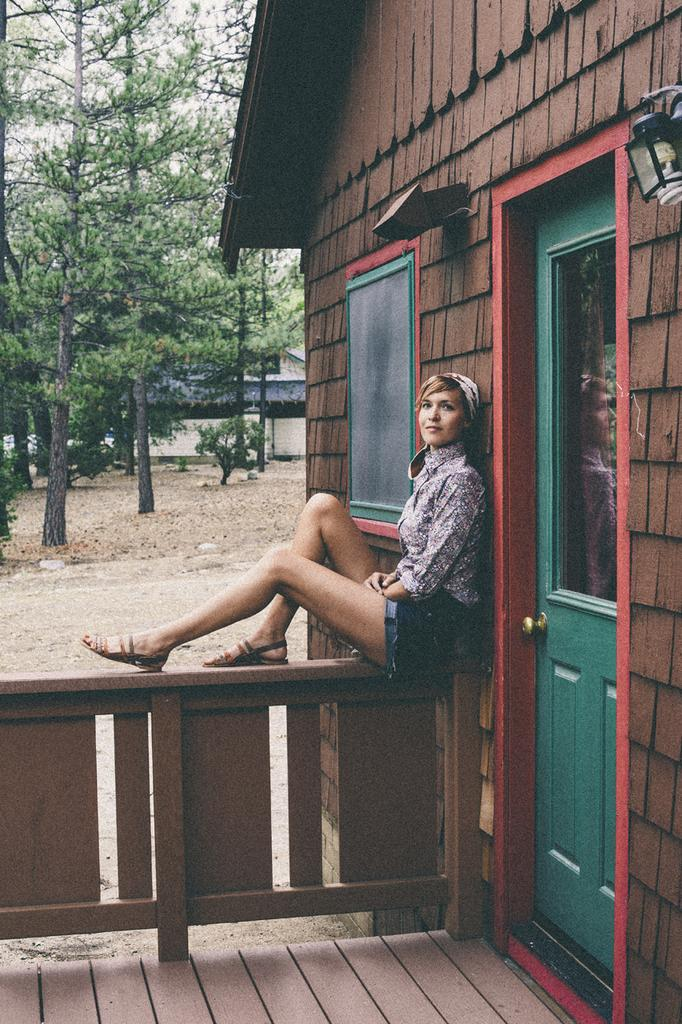What is the woman doing in the image? The woman is sitting on a wooden wall. What can be seen on the right side of the image? There is a house on the right side of the image. What type of vegetation is visible in the background of the image? There are trees in the background of the image. Can you tell me how many cameras the woman is holding in the image? There are no cameras visible in the image; the woman is simply sitting on the wooden wall. 